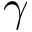Convert formula to latex. <formula><loc_0><loc_0><loc_500><loc_500>\gamma</formula> 